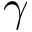Convert formula to latex. <formula><loc_0><loc_0><loc_500><loc_500>\gamma</formula> 